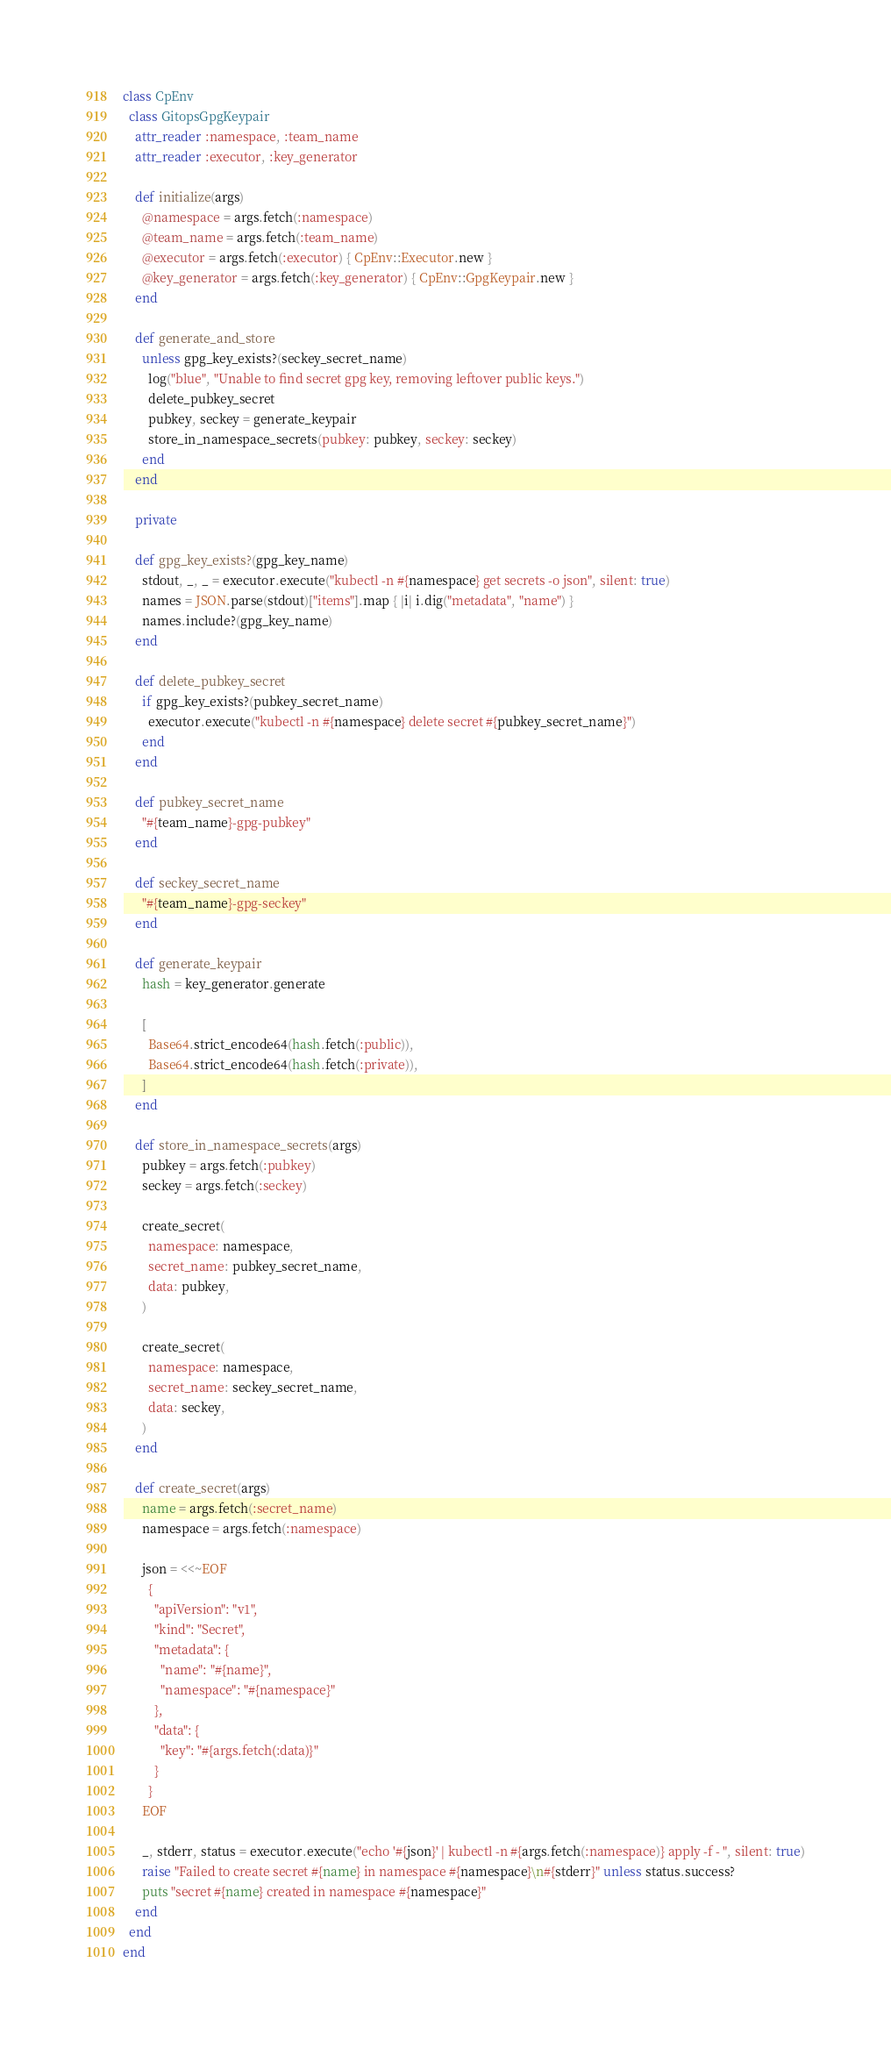<code> <loc_0><loc_0><loc_500><loc_500><_Ruby_>class CpEnv
  class GitopsGpgKeypair
    attr_reader :namespace, :team_name
    attr_reader :executor, :key_generator

    def initialize(args)
      @namespace = args.fetch(:namespace)
      @team_name = args.fetch(:team_name)
      @executor = args.fetch(:executor) { CpEnv::Executor.new }
      @key_generator = args.fetch(:key_generator) { CpEnv::GpgKeypair.new }
    end

    def generate_and_store
      unless gpg_key_exists?(seckey_secret_name)
        log("blue", "Unable to find secret gpg key, removing leftover public keys.")
        delete_pubkey_secret
        pubkey, seckey = generate_keypair
        store_in_namespace_secrets(pubkey: pubkey, seckey: seckey)
      end
    end

    private

    def gpg_key_exists?(gpg_key_name)
      stdout, _, _ = executor.execute("kubectl -n #{namespace} get secrets -o json", silent: true)
      names = JSON.parse(stdout)["items"].map { |i| i.dig("metadata", "name") }
      names.include?(gpg_key_name)
    end

    def delete_pubkey_secret
      if gpg_key_exists?(pubkey_secret_name)
        executor.execute("kubectl -n #{namespace} delete secret #{pubkey_secret_name}")
      end
    end

    def pubkey_secret_name
      "#{team_name}-gpg-pubkey"
    end

    def seckey_secret_name
      "#{team_name}-gpg-seckey"
    end

    def generate_keypair
      hash = key_generator.generate

      [
        Base64.strict_encode64(hash.fetch(:public)),
        Base64.strict_encode64(hash.fetch(:private)),
      ]
    end

    def store_in_namespace_secrets(args)
      pubkey = args.fetch(:pubkey)
      seckey = args.fetch(:seckey)

      create_secret(
        namespace: namespace,
        secret_name: pubkey_secret_name,
        data: pubkey,
      )

      create_secret(
        namespace: namespace,
        secret_name: seckey_secret_name,
        data: seckey,
      )
    end

    def create_secret(args)
      name = args.fetch(:secret_name)
      namespace = args.fetch(:namespace)

      json = <<~EOF
        {
          "apiVersion": "v1",
          "kind": "Secret",
          "metadata": {
            "name": "#{name}",
            "namespace": "#{namespace}"
          },
          "data": {
            "key": "#{args.fetch(:data)}"
          }
        }
      EOF

      _, stderr, status = executor.execute("echo '#{json}' | kubectl -n #{args.fetch(:namespace)} apply -f - ", silent: true)
      raise "Failed to create secret #{name} in namespace #{namespace}\n#{stderr}" unless status.success?
      puts "secret #{name} created in namespace #{namespace}"
    end
  end
end
</code> 